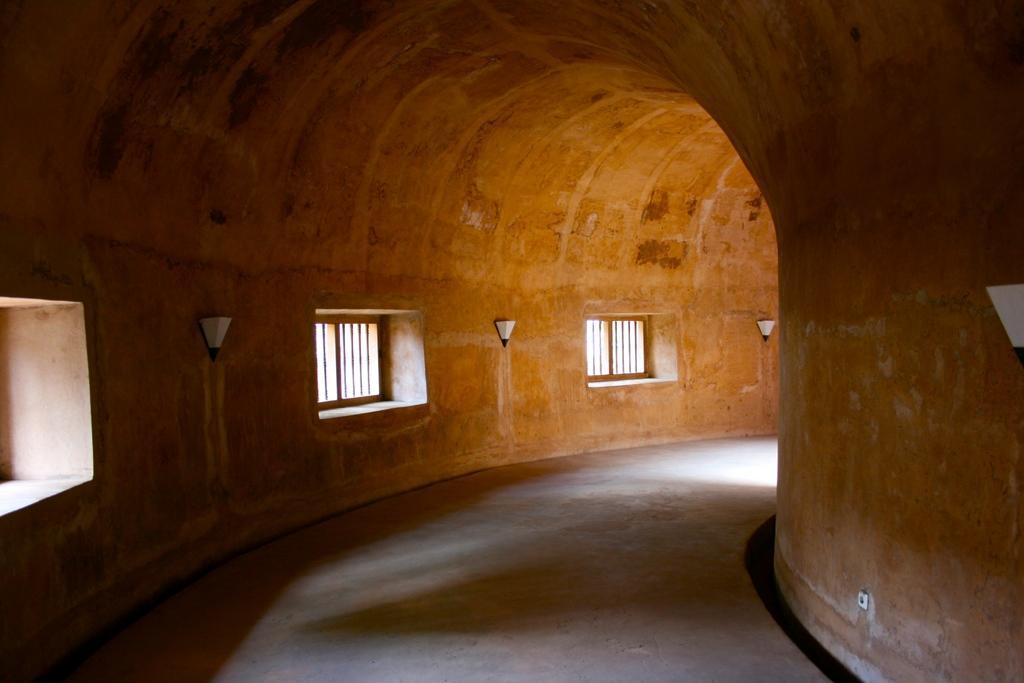Can you describe this image briefly? This image is taken indoors. At the bottom of the image there is a floor. In the middle of the image there are two walls with windows and there are a few lights. At the top of the image there is a roof. This image is taken in a cave. 